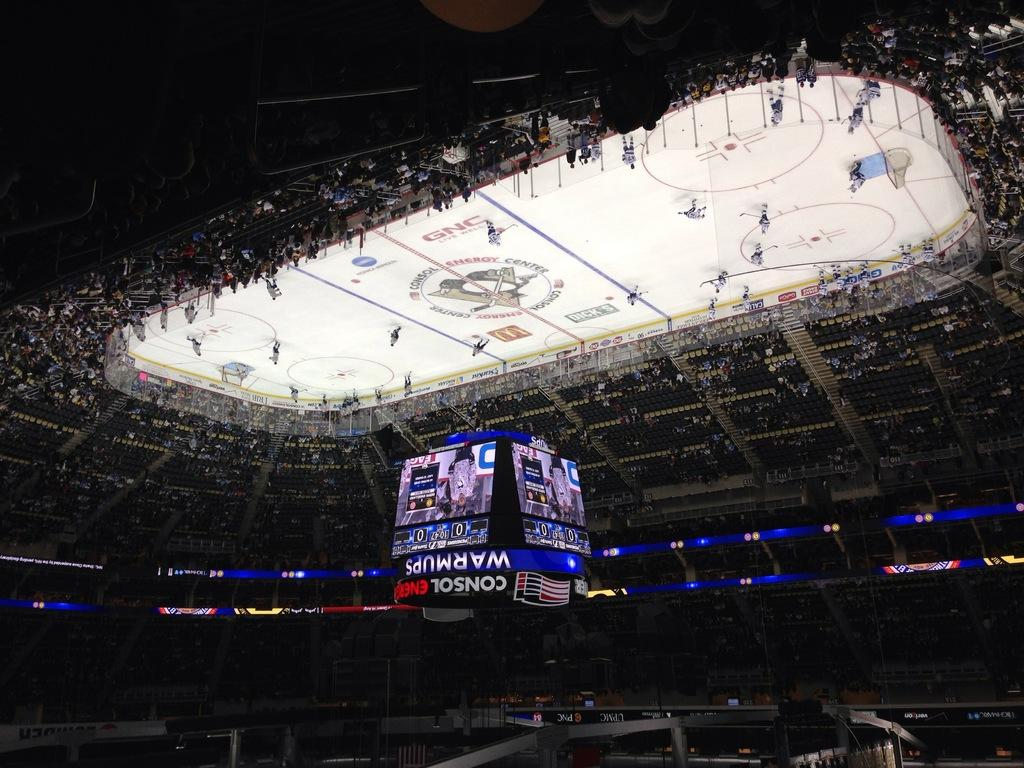<image>
Give a short and clear explanation of the subsequent image. An upside down picture of a hockey rink with the word warmups above it. 